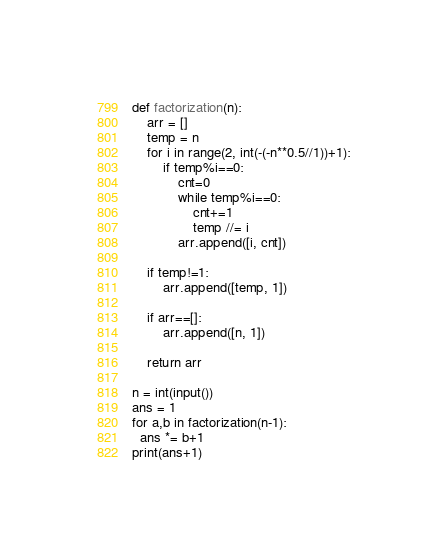<code> <loc_0><loc_0><loc_500><loc_500><_Python_>def factorization(n):
    arr = []
    temp = n
    for i in range(2, int(-(-n**0.5//1))+1):
        if temp%i==0:
            cnt=0
            while temp%i==0:
                cnt+=1
                temp //= i
            arr.append([i, cnt])

    if temp!=1:
        arr.append([temp, 1])

    if arr==[]:
        arr.append([n, 1])

    return arr

n = int(input())
ans = 1
for a,b in factorization(n-1):
  ans *= b+1
print(ans+1)</code> 